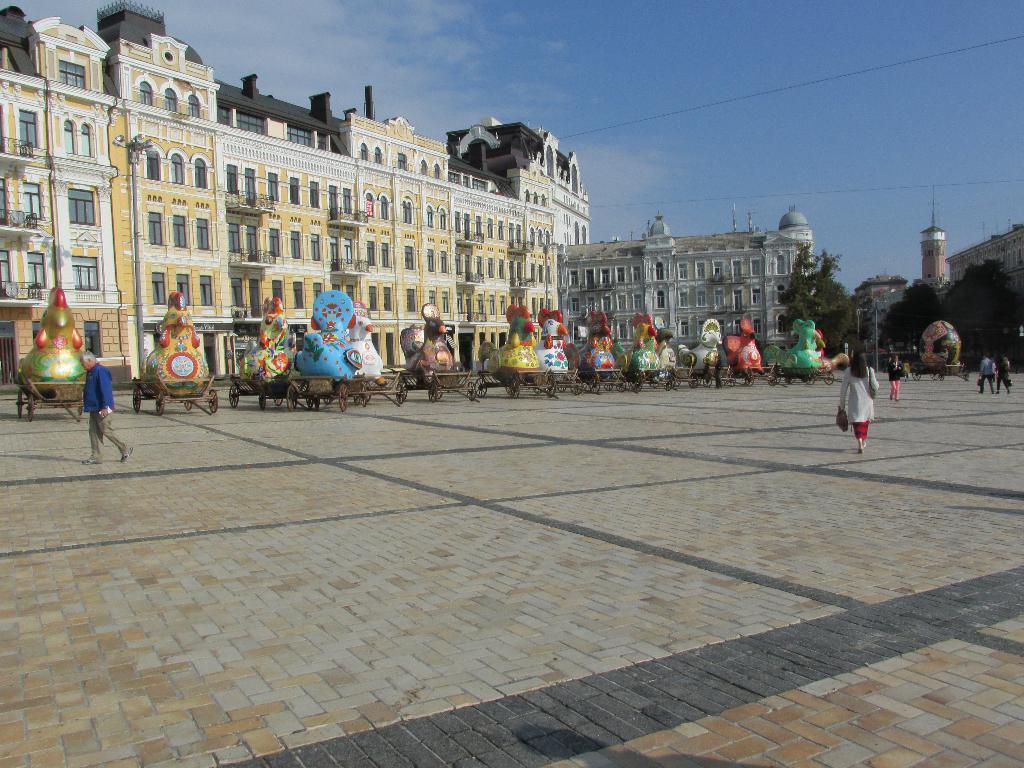Could you give a brief overview of what you see in this image? In this image, we can see so many carts with some idols. Here we can see few people are walking on the platform. Background there are so many buildings with walls and windows. Here we can see trees, poles and sky. 